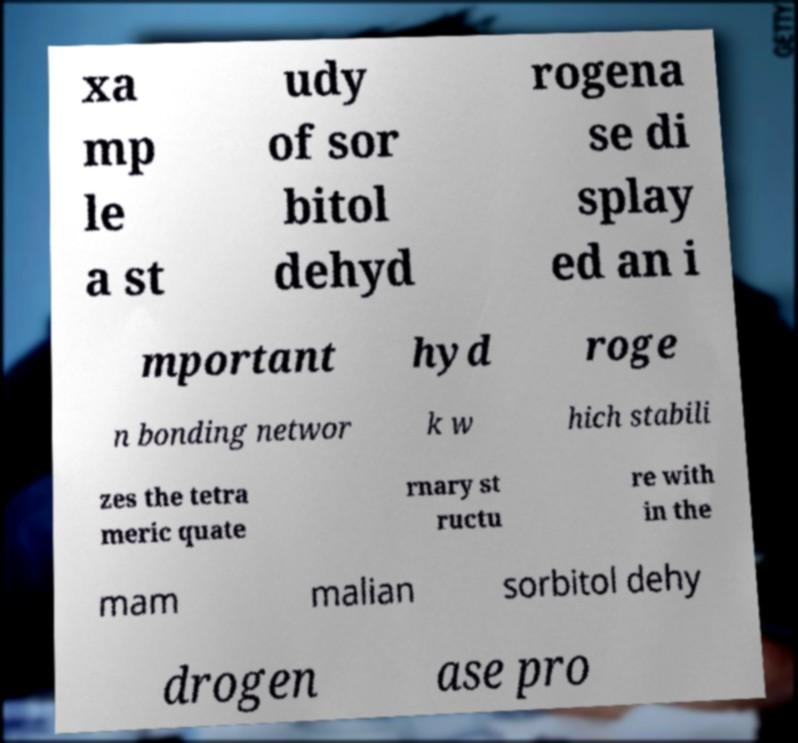I need the written content from this picture converted into text. Can you do that? xa mp le a st udy of sor bitol dehyd rogena se di splay ed an i mportant hyd roge n bonding networ k w hich stabili zes the tetra meric quate rnary st ructu re with in the mam malian sorbitol dehy drogen ase pro 